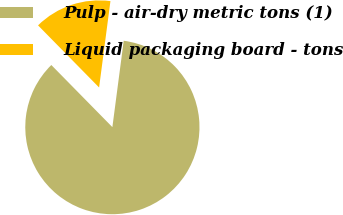Convert chart to OTSL. <chart><loc_0><loc_0><loc_500><loc_500><pie_chart><fcel>Pulp - air-dry metric tons (1)<fcel>Liquid packaging board - tons<nl><fcel>85.56%<fcel>14.44%<nl></chart> 